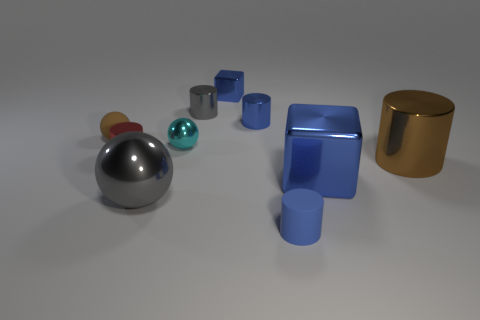There is another shiny block that is the same color as the tiny metallic cube; what is its size?
Ensure brevity in your answer.  Large. Are there any small shiny things behind the matte sphere?
Your answer should be very brief. Yes. Do the large blue thing and the gray object that is in front of the blue metallic cylinder have the same shape?
Ensure brevity in your answer.  No. How many other objects are the same material as the red thing?
Your answer should be very brief. 7. The tiny cylinder that is left of the small ball in front of the tiny matte object that is behind the big brown thing is what color?
Provide a succinct answer. Red. What is the shape of the tiny blue metal thing in front of the blue metal block that is behind the matte sphere?
Make the answer very short. Cylinder. Are there more large gray things that are to the left of the cyan shiny sphere than large red matte objects?
Give a very brief answer. Yes. Do the tiny rubber thing on the left side of the blue metal cylinder and the red metal object have the same shape?
Offer a terse response. No. Are there any other metal objects of the same shape as the big blue metallic object?
Provide a succinct answer. Yes. What number of objects are either tiny shiny cylinders in front of the tiny gray cylinder or big spheres?
Your answer should be very brief. 3. 